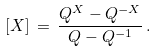<formula> <loc_0><loc_0><loc_500><loc_500>[ X ] \, = \, \frac { Q ^ { X } - Q ^ { - X } } { Q - Q ^ { - 1 } } \, .</formula> 